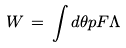<formula> <loc_0><loc_0><loc_500><loc_500>W \, = \, \int d \theta p F \Lambda</formula> 